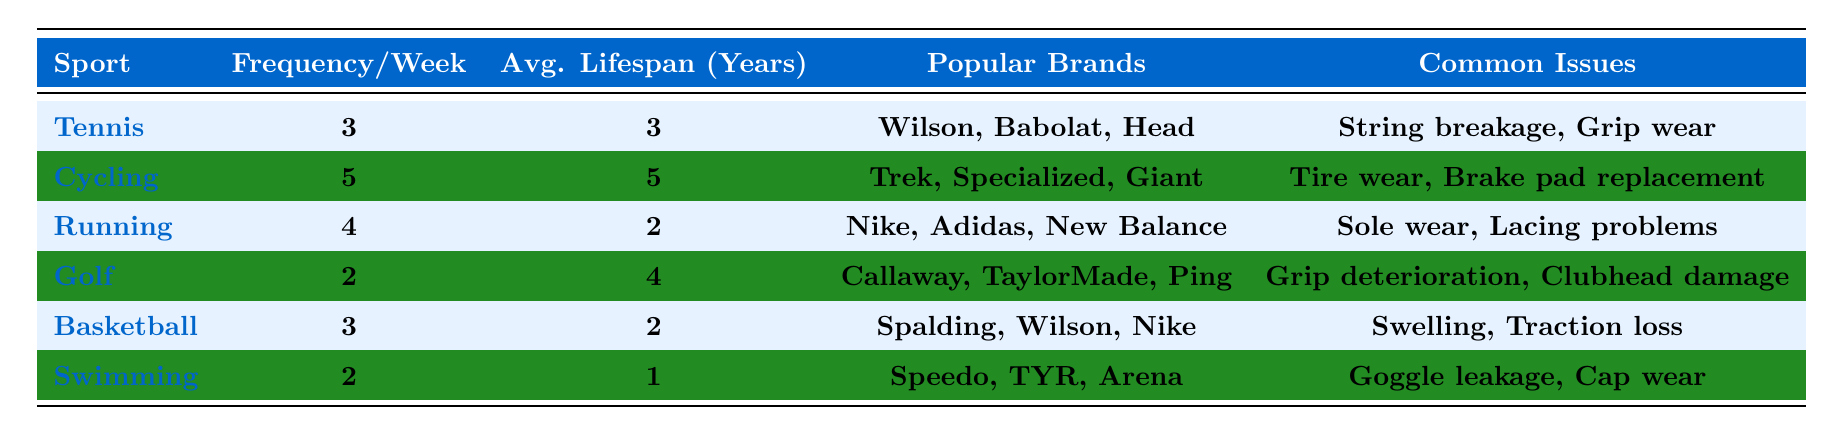What sport has the highest frequency of equipment usage per week? The frequency of equipment usage per week is highest for cycling at 5 times. By comparing the frequency per week for each sport listed in the table, cycling is the only sport that has a higher frequency than the others.
Answer: Cycling Which sport has the shortest average equipment lifespan? The average equipment lifespan is shortest for swimming, which lasts only 1 year. Checking the lifespan data for each sport, swimming has the lowest value.
Answer: Swimming How many times per week do recreational athletes typically play golf? According to the table, recreational athletes typically play golf 2 times per week, as indicated in the frequency column for that sport.
Answer: 2 What is the average frequency of equipment usage for basketball and tennis combined? To find the average frequency for basketball and tennis, we add their frequencies (3 for tennis and 3 for basketball) and divide by 2. Thus, (3 + 3)/2 = 3.
Answer: 3 Is it true that running equipment lasts longer on average than basketball equipment? Yes, it's true. The average equipment lifespan for running is 2 years, while for basketball, it is also 2 years. Since they are equal, running does not last longer but they are the same.
Answer: Yes Which two sports have the same frequency of usage per week, and what is that frequency? The two sports that have the same frequency per week are tennis and basketball, both at 3 times per week. Comparing the frequency data in the table, these are identified as equal values.
Answer: Tennis and Basketball; 3 What are the common issues associated with cycling equipment? The common issues for cycling equipment include tire wear and brake pad replacement. These issues are listed in the table under the cycling section.
Answer: Tire wear, Brake pad replacement Calculate the total frequency of usage per week for all sports listed in the table. To calculate the total frequency, we add up the frequencies per week: 3 (Tennis) + 5 (Cycling) + 4 (Running) + 2 (Golf) + 3 (Basketball) + 2 (Swimming) = 19.
Answer: 19 What is the average lifespan of equipment for sports that have a frequency of 2 times per week? The sports with a frequency of 2 times per week are golf and swimming. Their average lifespans are 4 and 1 year respectively. To calculate the average, (4 + 1)/2 = 2.5 years.
Answer: 2.5 What popular brands are associated with tennis equipment? The popular brands associated with tennis equipment are Wilson, Babolat, and Head, as noted in the table.
Answer: Wilson, Babolat, Head 